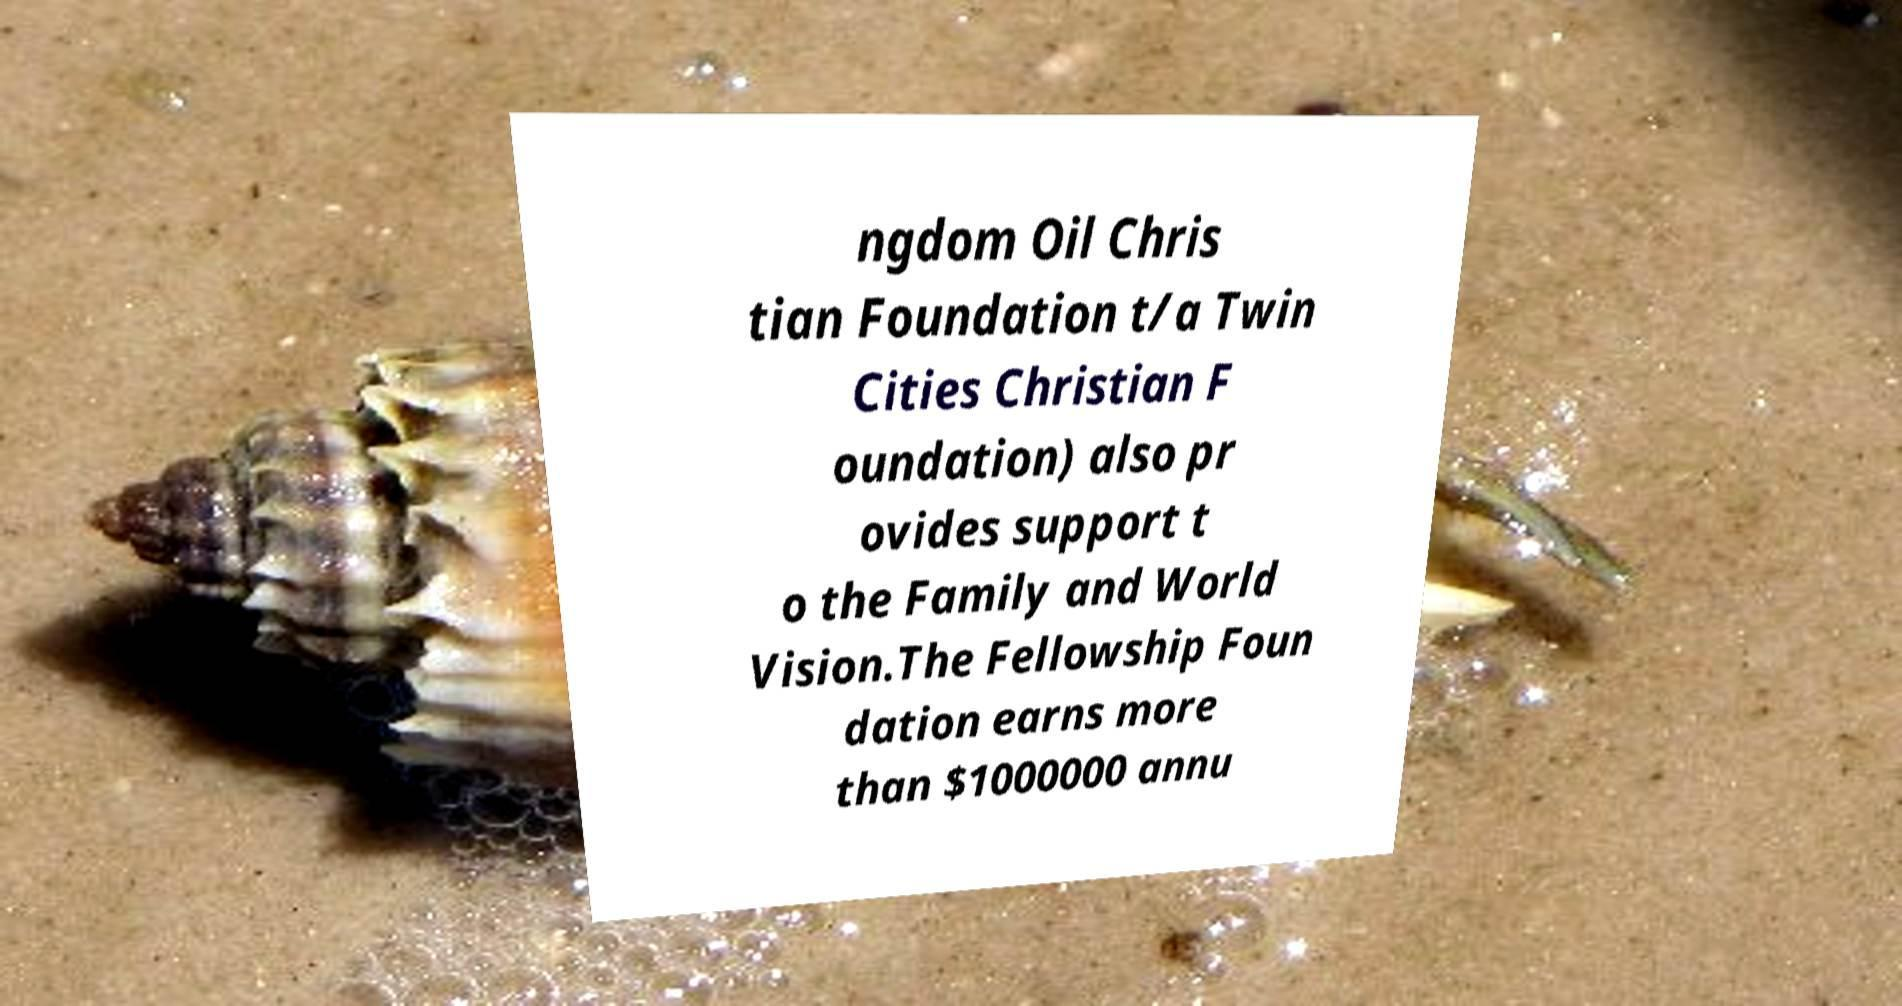Could you assist in decoding the text presented in this image and type it out clearly? ngdom Oil Chris tian Foundation t/a Twin Cities Christian F oundation) also pr ovides support t o the Family and World Vision.The Fellowship Foun dation earns more than $1000000 annu 